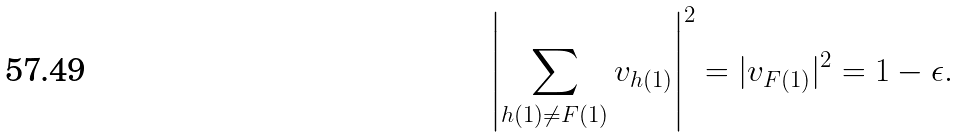<formula> <loc_0><loc_0><loc_500><loc_500>\left | \sum _ { h ( 1 ) \ne F ( 1 ) } v _ { h ( 1 ) } \right | ^ { 2 } = | v _ { F ( 1 ) } | ^ { 2 } = 1 - \epsilon .</formula> 